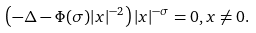<formula> <loc_0><loc_0><loc_500><loc_500>\left ( - \Delta - \Phi ( \sigma ) | x | ^ { - 2 } \right ) | x | ^ { - \sigma } = 0 , x \neq 0 .</formula> 